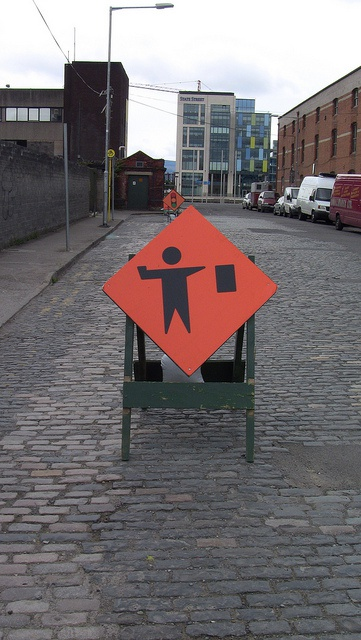Describe the objects in this image and their specific colors. I can see car in white, maroon, gray, black, and purple tones, car in white, lightgray, black, gray, and darkgray tones, car in white, black, gray, purple, and darkgray tones, car in white, darkgray, black, gray, and lightgray tones, and car in white, gray, black, lightgray, and darkgray tones in this image. 